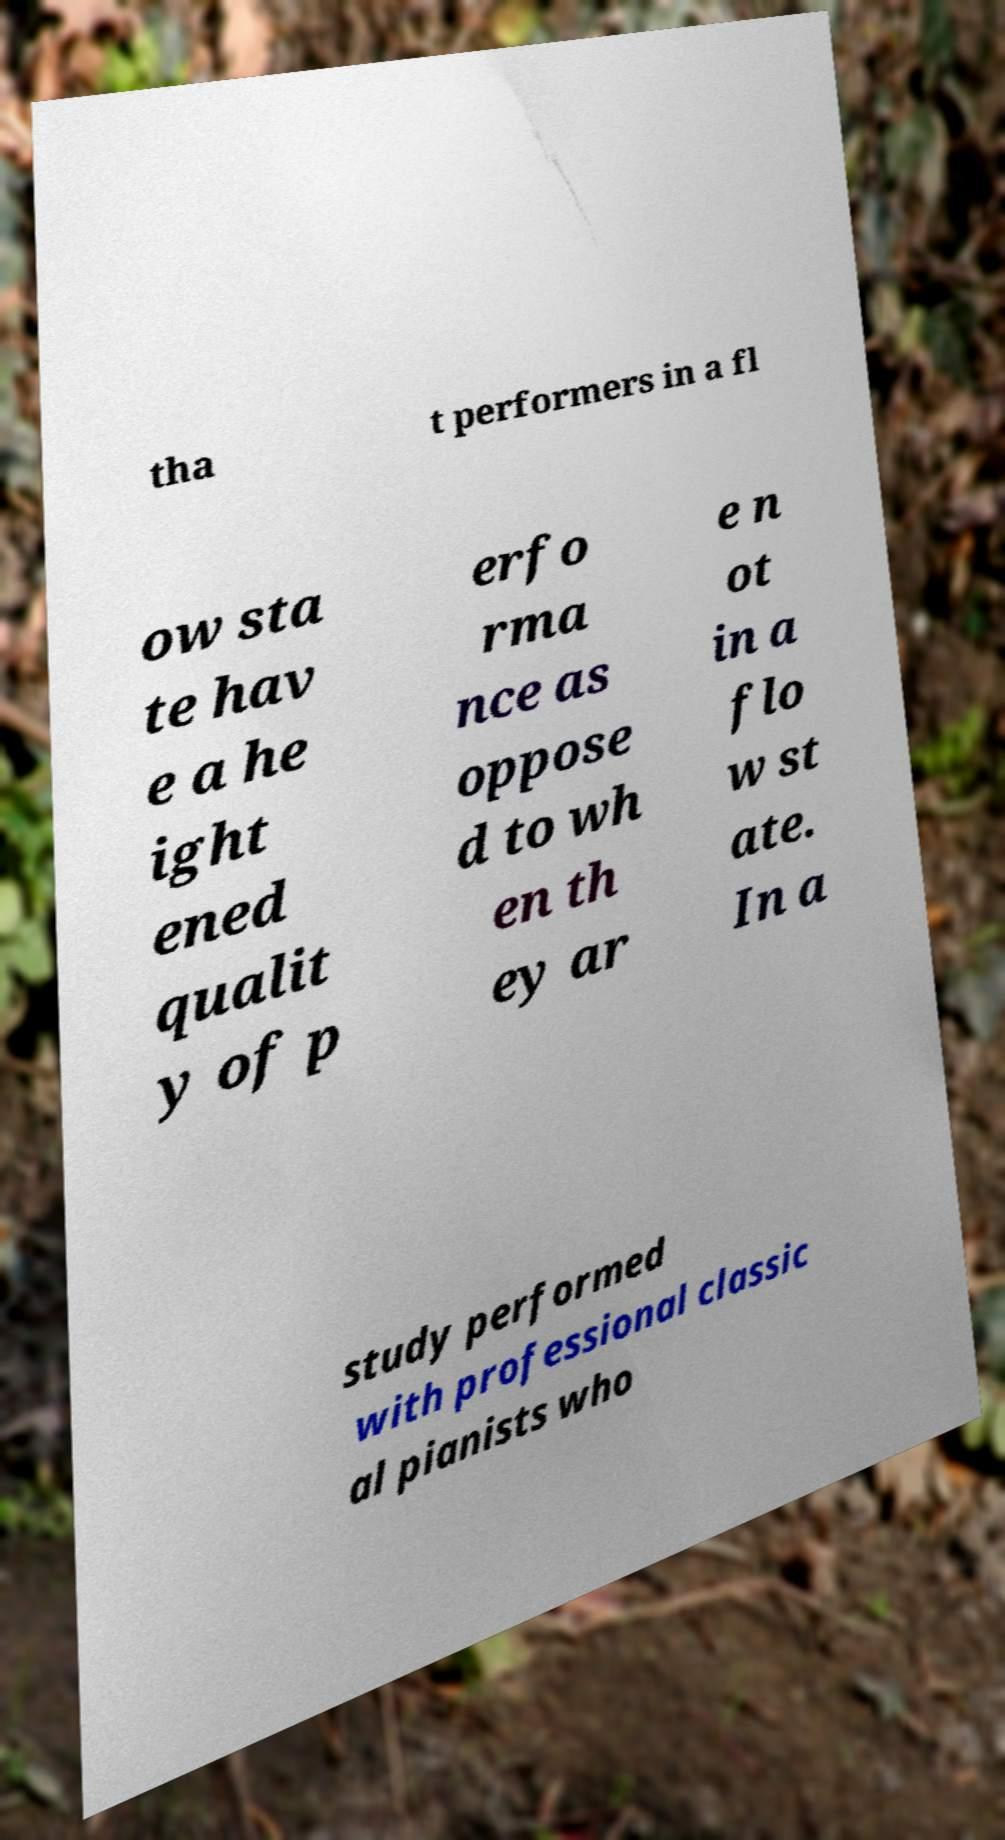Could you assist in decoding the text presented in this image and type it out clearly? tha t performers in a fl ow sta te hav e a he ight ened qualit y of p erfo rma nce as oppose d to wh en th ey ar e n ot in a flo w st ate. In a study performed with professional classic al pianists who 